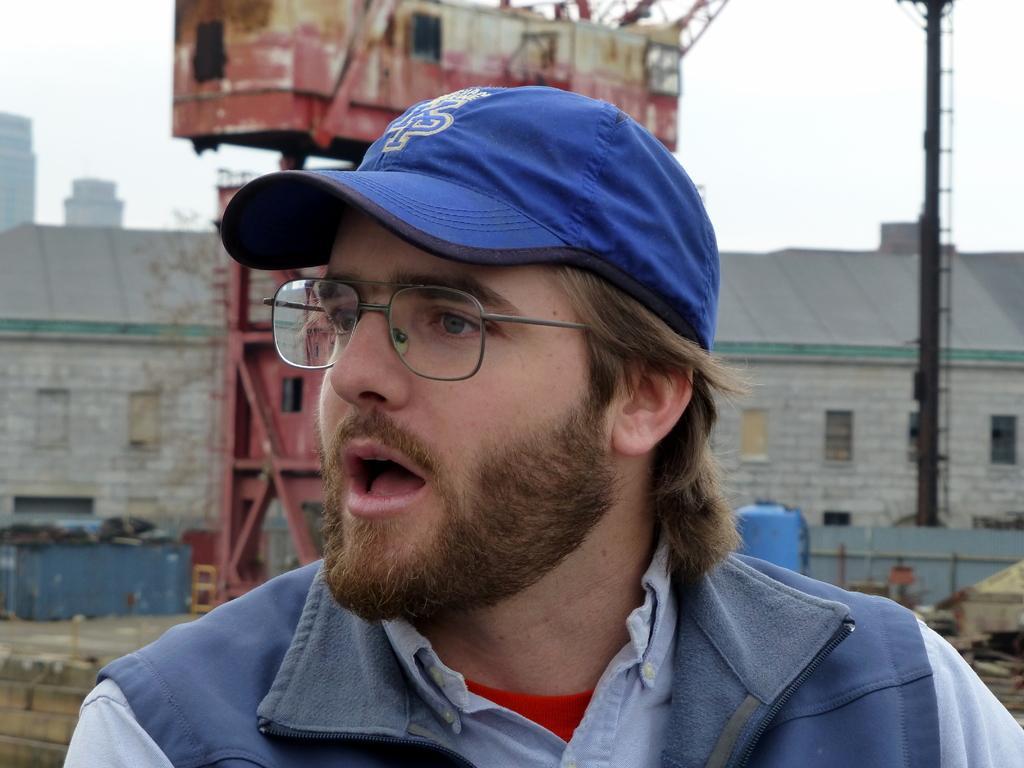Can you describe this image briefly? In this image we can see a man with cap, in the background there is a crane, an iron pole, few buildings, a blue color object and the sky. 